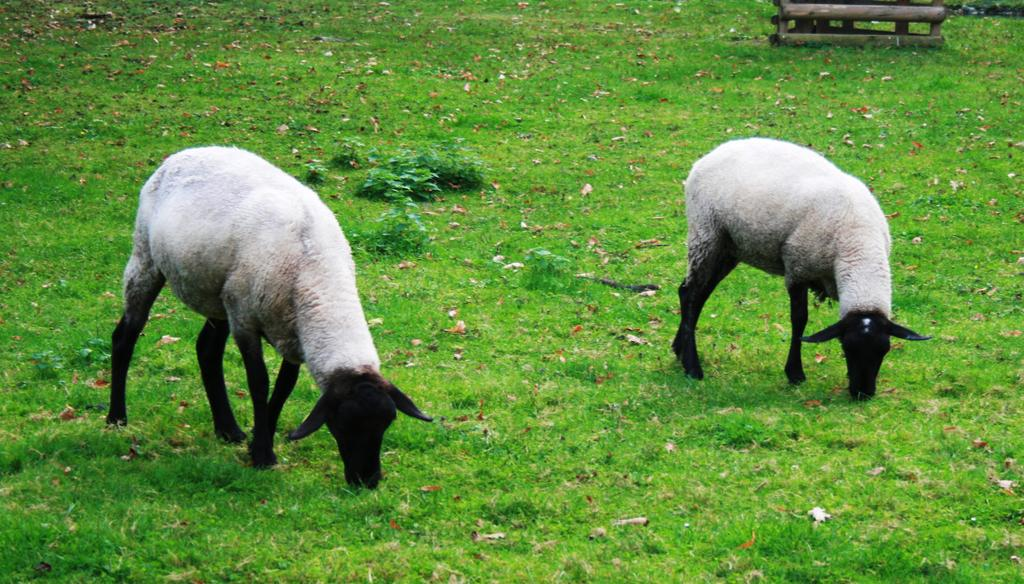What type of animals are on the ground in the image? There are sheep on the ground in the image. What type of vegetation is present in the image? There is grass and plants in the image. Can you describe the wooden object visible at the top of the image? Unfortunately, the facts provided do not give enough information to describe the wooden object. What type of bone can be seen in the image? There is no bone present in the image. What type of band is playing music in the image? There is no band present in the image. 